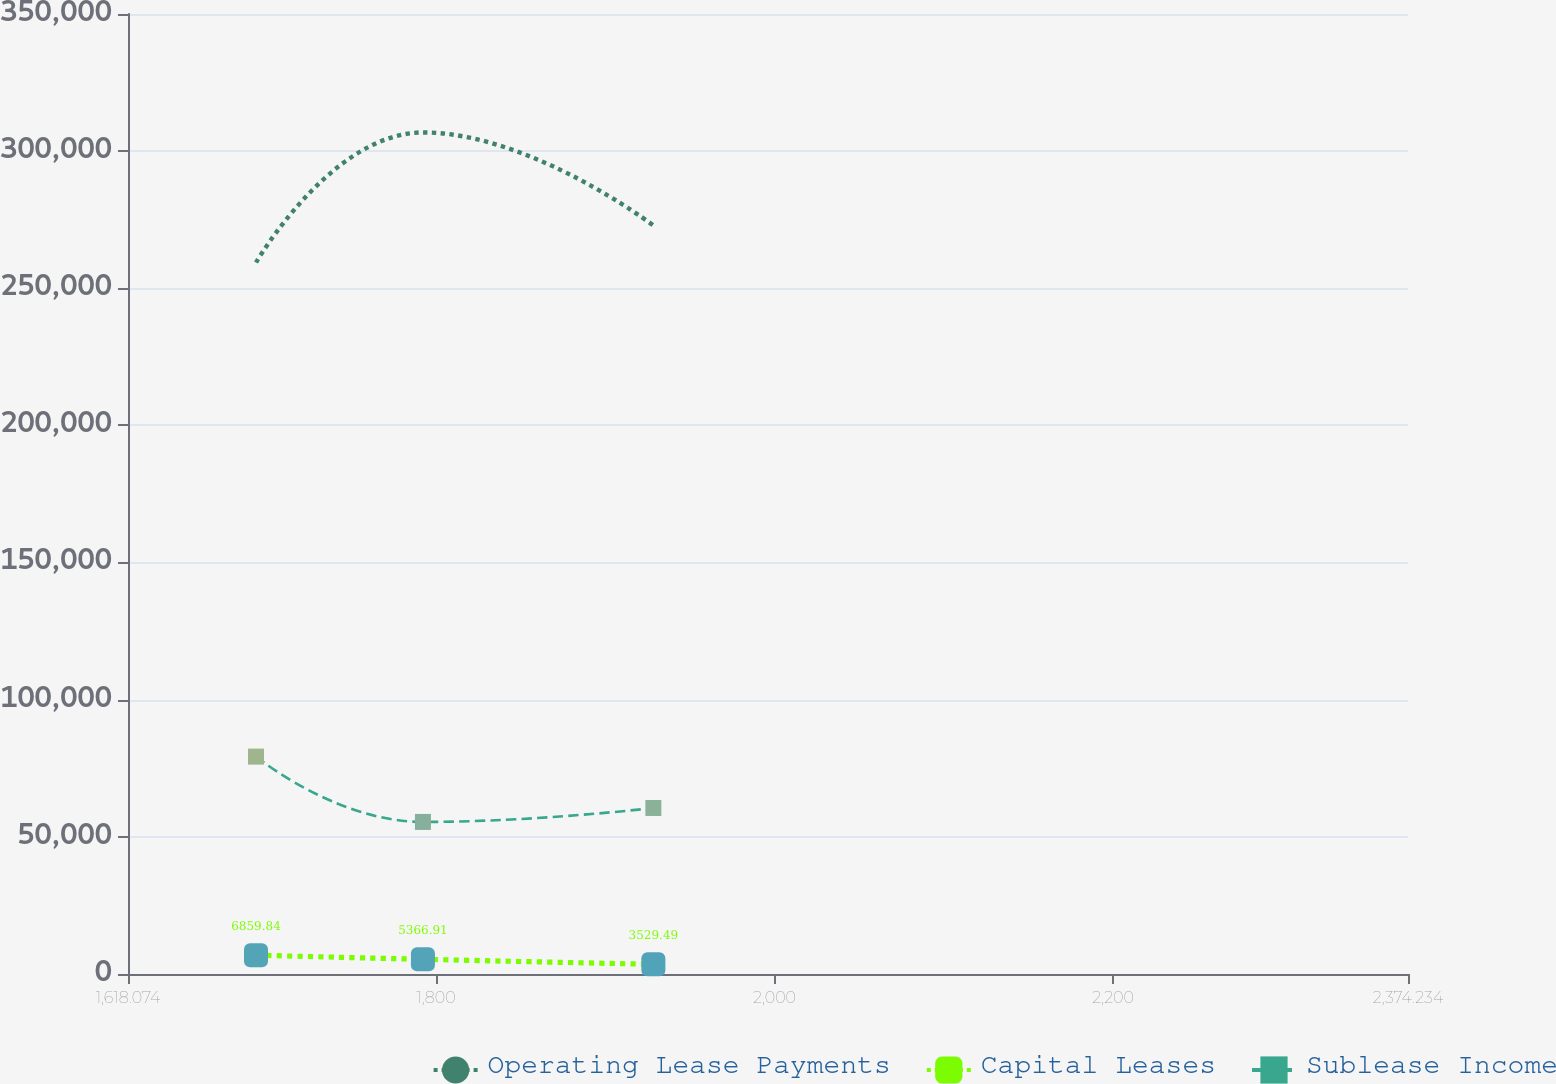Convert chart to OTSL. <chart><loc_0><loc_0><loc_500><loc_500><line_chart><ecel><fcel>Operating Lease Payments<fcel>Capital Leases<fcel>Sublease Income<nl><fcel>1693.69<fcel>259395<fcel>6859.84<fcel>79259.8<nl><fcel>1792.31<fcel>306819<fcel>5366.91<fcel>55441<nl><fcel>1928.44<fcel>272920<fcel>3529.49<fcel>60532.1<nl><fcel>2378.21<fcel>198959<fcel>2548.99<fcel>65623.2<nl><fcel>2449.85<fcel>229717<fcel>3098.41<fcel>28349<nl></chart> 